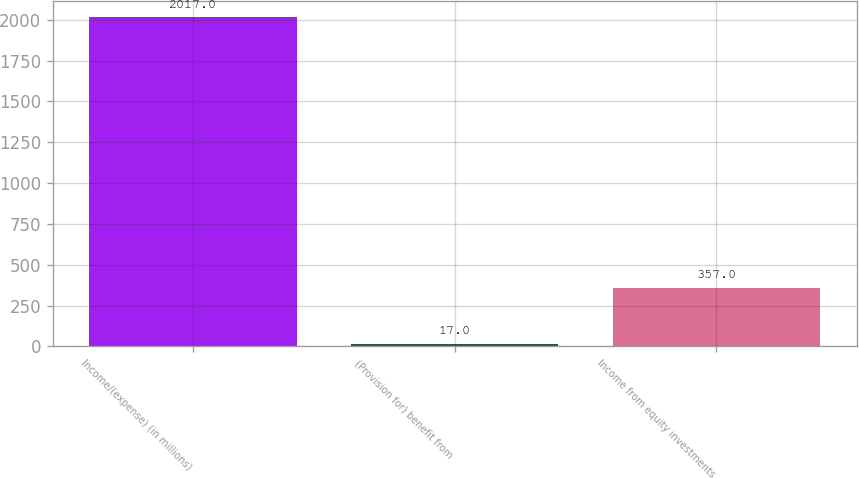Convert chart. <chart><loc_0><loc_0><loc_500><loc_500><bar_chart><fcel>Income/(expense) (in millions)<fcel>(Provision for) benefit from<fcel>Income from equity investments<nl><fcel>2017<fcel>17<fcel>357<nl></chart> 